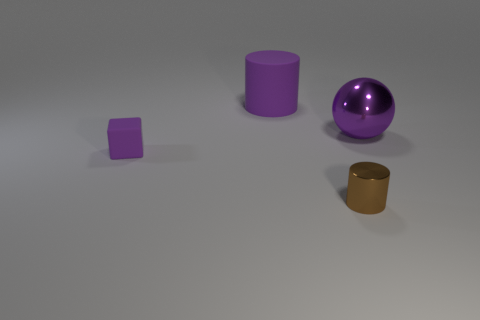Is the color of the block the same as the large ball?
Provide a succinct answer. Yes. Is the purple block made of the same material as the small brown cylinder?
Make the answer very short. No. Are there fewer metallic objects than large rubber cubes?
Keep it short and to the point. No. Do the large purple matte object and the brown shiny object have the same shape?
Ensure brevity in your answer.  Yes. The matte cylinder has what color?
Give a very brief answer. Purple. How many other things are there of the same material as the large purple ball?
Your response must be concise. 1. How many yellow objects are either large balls or rubber things?
Ensure brevity in your answer.  0. Do the purple rubber object behind the tiny purple thing and the small object that is right of the block have the same shape?
Offer a terse response. Yes. There is a block; does it have the same color as the metallic object behind the tiny brown object?
Your answer should be compact. Yes. There is a large thing that is on the right side of the tiny shiny cylinder; is it the same color as the tiny rubber thing?
Ensure brevity in your answer.  Yes. 